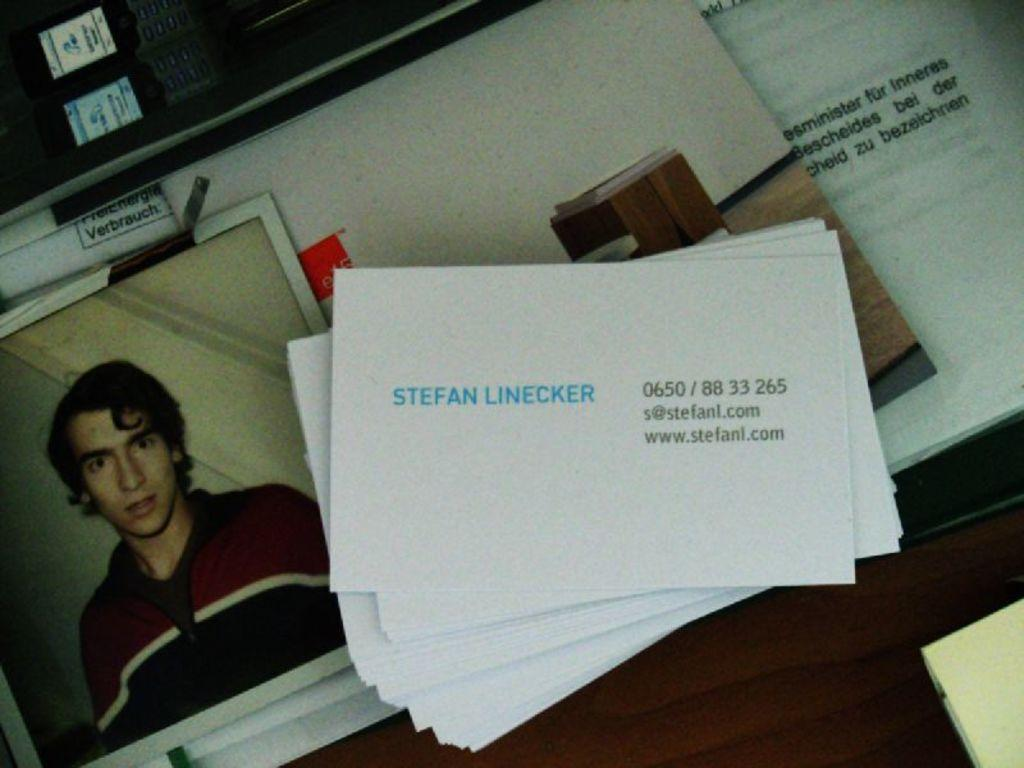<image>
Offer a succinct explanation of the picture presented. Stephan Linecker is in the photo and he is wearing a zip up sweater. 